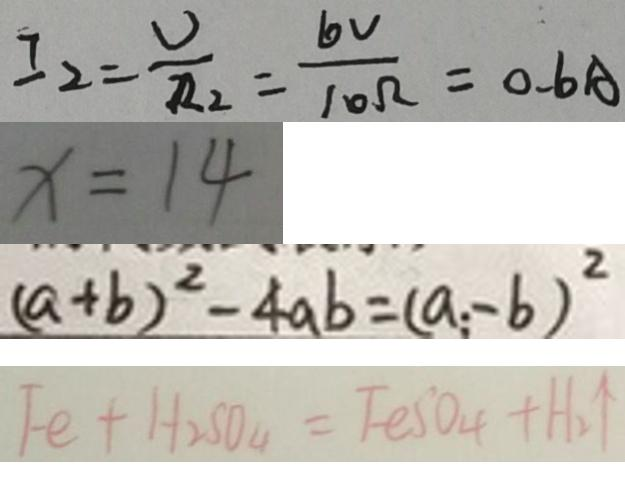<formula> <loc_0><loc_0><loc_500><loc_500>I _ { 2 } = \frac { U } { R _ { 2 } } = \frac { 6 v } { 1 0 \Omega } = 0 . 6 A 
 x = 1 4 
 ( a + b ) ^ { 2 } - 4 a b = ( a - b ) ^ { 2 } 
 F e + H _ { 2 } S O _ { 4 } = F e S O _ { 4 } + H _ { 2 } \uparrow</formula> 